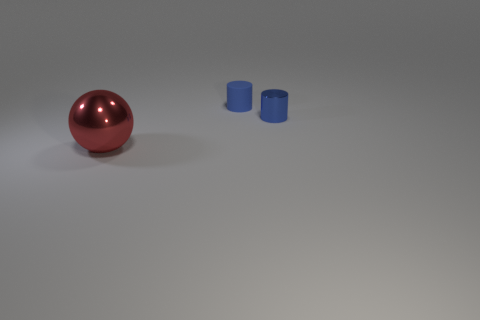There is a tiny rubber object; is it the same shape as the metallic thing that is behind the large metallic sphere?
Keep it short and to the point. Yes. Are there any other blue objects of the same shape as the big thing?
Keep it short and to the point. No. What is the shape of the blue object that is on the left side of the metal object that is behind the big red shiny ball?
Ensure brevity in your answer.  Cylinder. What is the shape of the small blue object to the right of the matte cylinder?
Make the answer very short. Cylinder. Do the object that is in front of the small blue metal cylinder and the small cylinder that is left of the small metallic cylinder have the same color?
Your response must be concise. No. How many things are both in front of the small blue metal thing and behind the blue metal thing?
Provide a succinct answer. 0. There is a cylinder that is the same material as the large red object; what is its size?
Provide a succinct answer. Small. The shiny sphere is what size?
Provide a short and direct response. Large. What is the material of the big red sphere?
Keep it short and to the point. Metal. There is a blue thing on the left side of the blue shiny object; does it have the same size as the large metallic object?
Offer a terse response. No. 